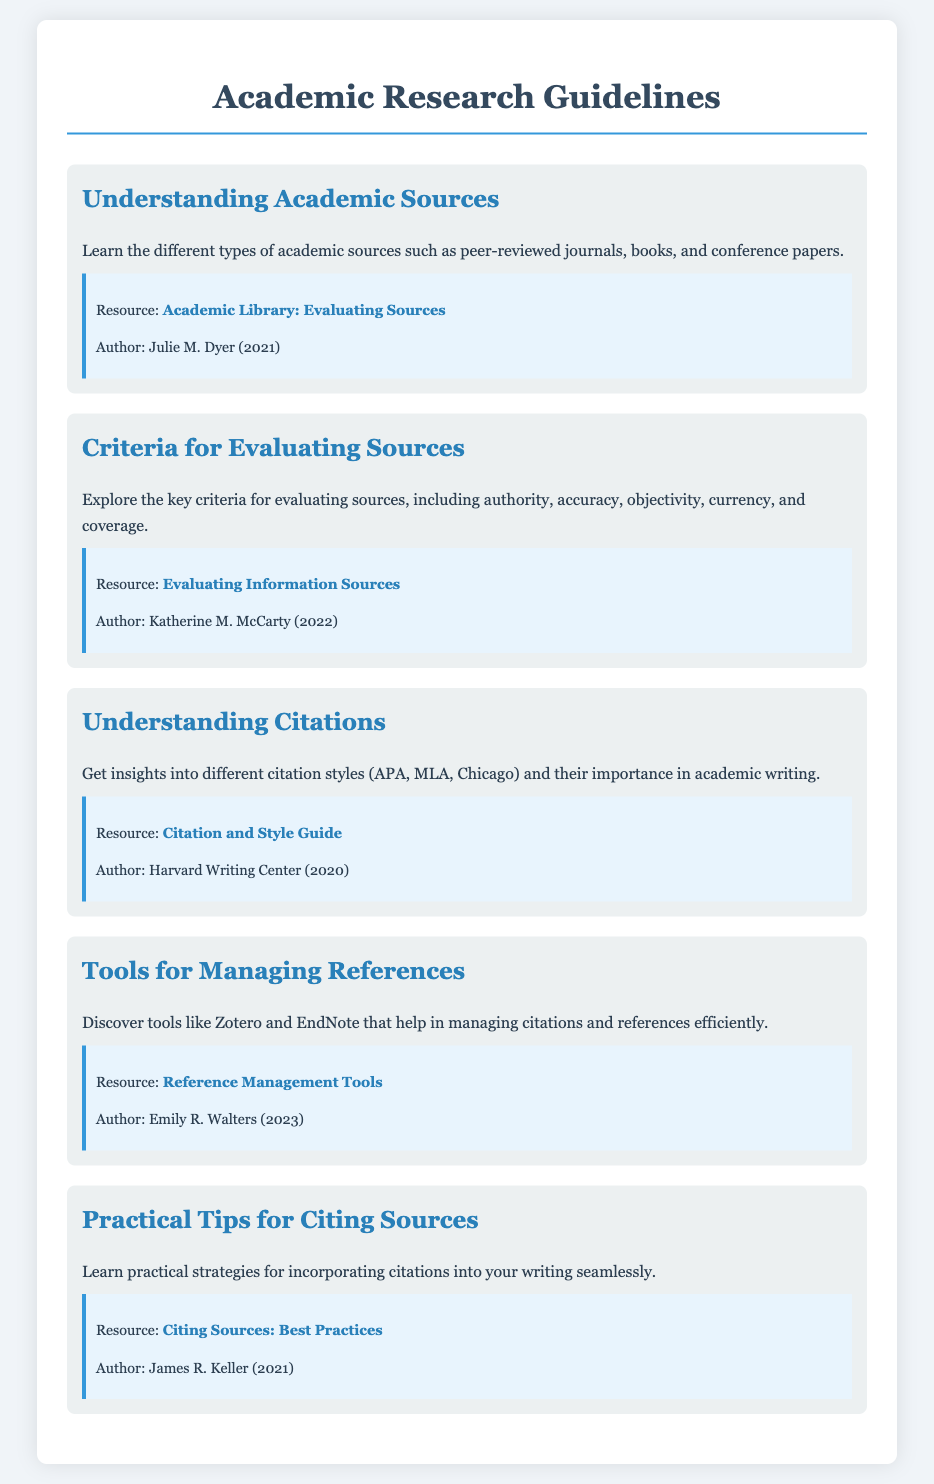What is the title of the document? The title of the document, as indicated in the header, provides the main theme of the content, which is about academic research guidelines.
Answer: Academic Research Guidelines Who authored the resource on evaluating sources? The document includes a section with resources that give credit to specific authors, in this case, Julie M. Dyer is the author of the resource on evaluating sources.
Answer: Julie M. Dyer What are the five key criteria for evaluating sources? The document lists authority, accuracy, objectivity, currency, and coverage as the criteria for evaluating sources in the respective section.
Answer: Authority, accuracy, objectivity, currency, coverage What type of tools are mentioned for managing references? The section about reference management indicates specific tools that assist with citation management, pointing out names such as Zotero and EndNote.
Answer: Zotero, EndNote In what year was the "Citation and Style Guide" published? The citation guide's publication year is noted in the resource section of the document, which gives context to its currency and relevance.
Answer: 2020 What color is used for the background of the menu items? The style information in the document specifies a light color for the background of menu items, which enhances readability and user experience.
Answer: Light gray Which author is associated with the resource on best practices for citing sources? This information is found in the resource section where authorship of the cited resources is clearly mentioned, specifically James R. Keller for the best practices guide.
Answer: James R. Keller How many main sections are there in the menu? The document lists distinct sections, providing an overview of the structured content focused on academic research guidelines.
Answer: Five 